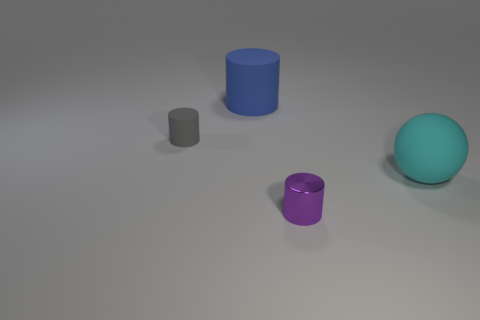There is a cylinder in front of the gray object; is its size the same as the matte thing that is to the right of the blue rubber cylinder?
Ensure brevity in your answer.  No. There is a rubber object right of the big object behind the big matte object in front of the small gray cylinder; what is its size?
Your response must be concise. Large. What shape is the small object left of the big rubber object behind the big matte sphere behind the small purple cylinder?
Provide a succinct answer. Cylinder. What shape is the rubber thing that is in front of the tiny gray cylinder?
Provide a short and direct response. Sphere. Does the purple thing have the same material as the large object that is in front of the blue matte object?
Provide a succinct answer. No. What number of other objects are the same shape as the small rubber thing?
Your answer should be compact. 2. Are there any other things that are made of the same material as the tiny purple object?
Offer a terse response. No. There is a matte object to the left of the large object left of the cyan thing; what shape is it?
Offer a very short reply. Cylinder. There is a rubber object that is left of the blue cylinder; is it the same shape as the small shiny object?
Your answer should be very brief. Yes. Are there more purple metallic things on the right side of the small gray matte cylinder than blue matte things that are to the right of the tiny purple thing?
Your answer should be very brief. Yes. 